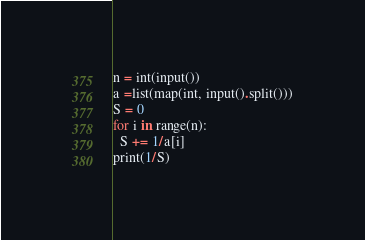Convert code to text. <code><loc_0><loc_0><loc_500><loc_500><_Python_>n = int(input())
a =list(map(int, input().split()))
S = 0
for i in range(n):
  S += 1/a[i]
print(1/S)</code> 